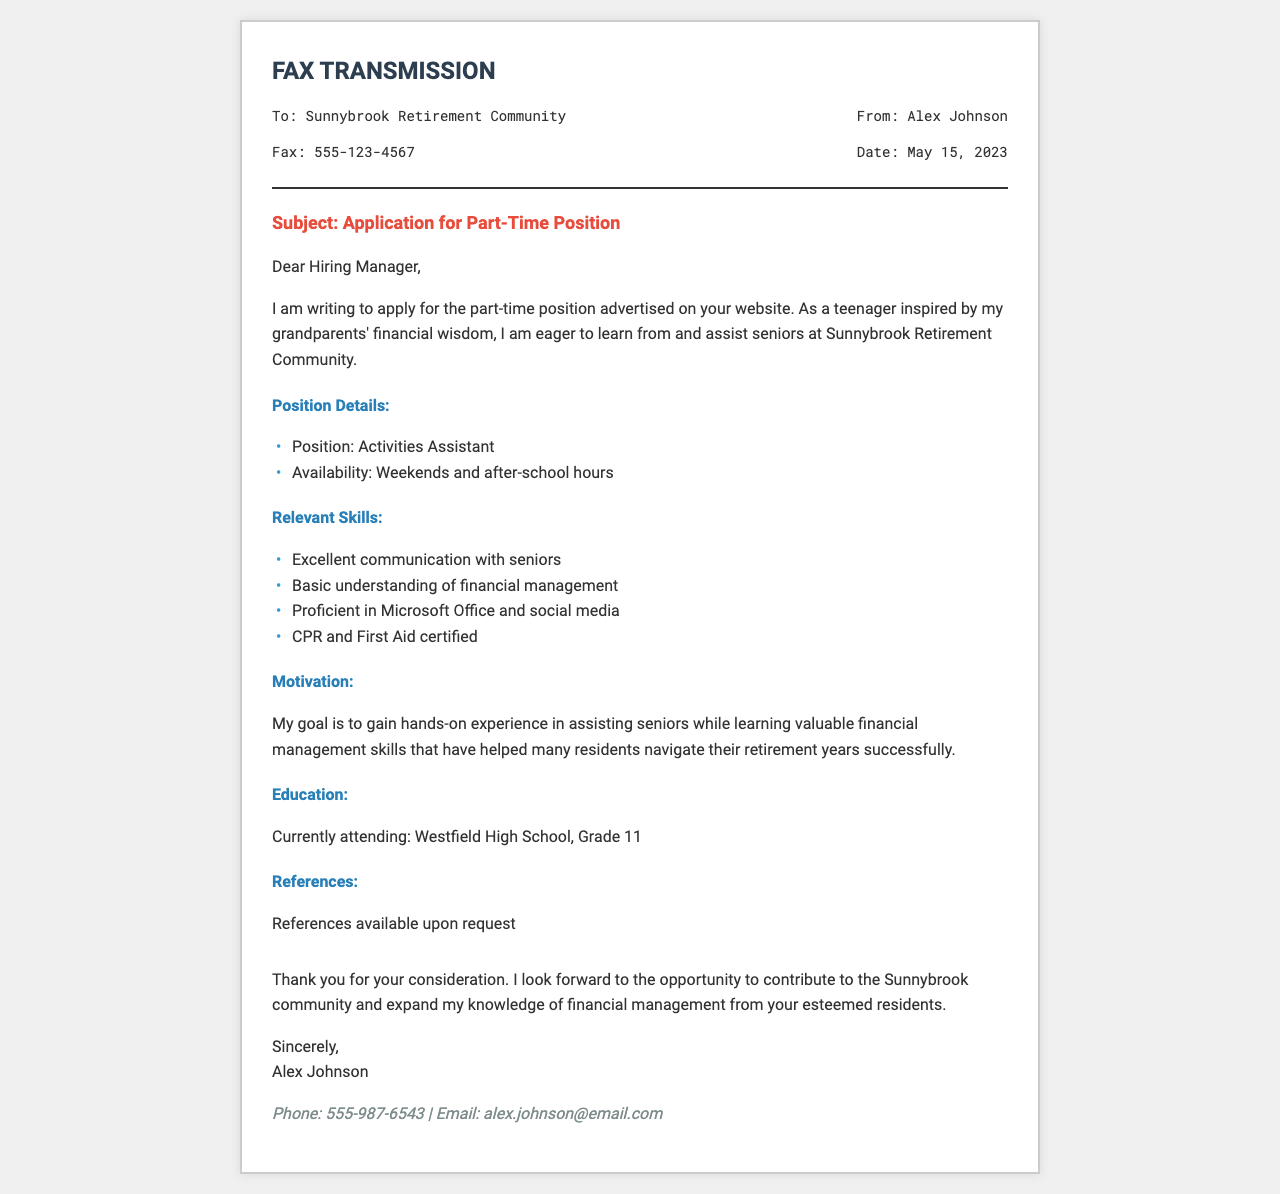What is the name of the applicant? The name of the applicant is mentioned at the end of the document as Alex Johnson.
Answer: Alex Johnson What is the position being applied for? The position title is provided in the section outlining the job details, stating the application is for the Activities Assistant role.
Answer: Activities Assistant What is the availability of the applicant? The applicant states their availability in the document as weekends and after-school hours.
Answer: Weekends and after-school hours What certifications does the applicant have? The relevant skills section includes certifications, specifically stating the applicant is CPR and First Aid certified.
Answer: CPR and First Aid certified Which high school is the applicant currently attending? The document mentions the applicant's school, which is Westfield High School and their current grade level.
Answer: Westfield High School What is the fax number of the retirement community? The retrieved contact information is found in the header section, with the fax number stated as 555-123-4567.
Answer: 555-123-4567 What does the applicant aim to gain from this position? The motivation section explains that the applicant aims to gain hands-on experience and learn about financial management from seniors.
Answer: Hands-on experience and financial management skills When was the application faxed? The date of the fax transmission is noted in the header, specifically on May 15, 2023.
Answer: May 15, 2023 What is the phone number provided for the applicant? The contact information section identifies the applicant's phone number as 555-987-6543.
Answer: 555-987-6543 